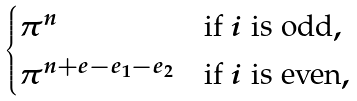Convert formula to latex. <formula><loc_0><loc_0><loc_500><loc_500>\begin{cases} \pi ^ { n } & \text {if $i$ is odd} , \\ \pi ^ { n + e - e _ { 1 } - e _ { 2 } } & \text {if $i$ is even} , \end{cases}</formula> 